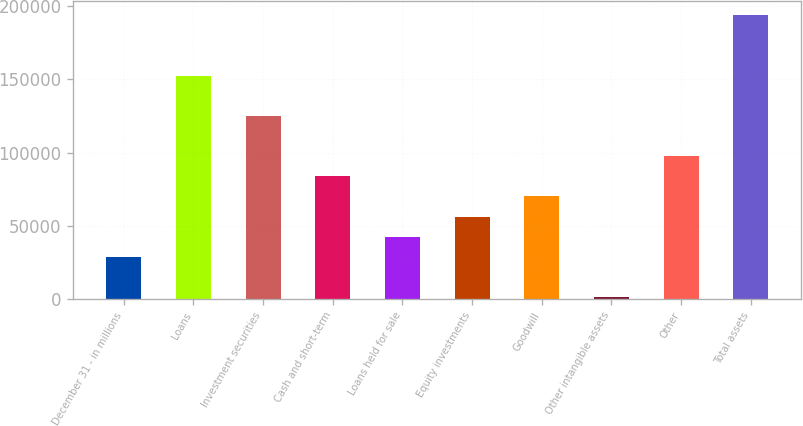<chart> <loc_0><loc_0><loc_500><loc_500><bar_chart><fcel>December 31 - in millions<fcel>Loans<fcel>Investment securities<fcel>Cash and short-term<fcel>Loans held for sale<fcel>Equity investments<fcel>Goodwill<fcel>Other intangible assets<fcel>Other<fcel>Total assets<nl><fcel>28700.8<fcel>152697<fcel>125143<fcel>83810.4<fcel>42478.2<fcel>56255.6<fcel>70033<fcel>1146<fcel>97587.8<fcel>194030<nl></chart> 